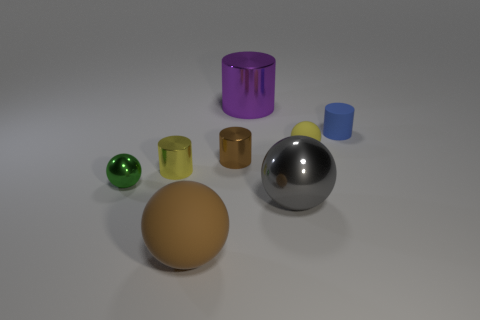Subtract all yellow cylinders. How many cylinders are left? 3 Subtract all brown spheres. How many spheres are left? 3 Add 2 tiny rubber cylinders. How many objects exist? 10 Subtract 4 balls. How many balls are left? 0 Add 8 large purple cylinders. How many large purple cylinders are left? 9 Add 2 big matte spheres. How many big matte spheres exist? 3 Subtract 0 yellow cubes. How many objects are left? 8 Subtract all blue cylinders. Subtract all blue spheres. How many cylinders are left? 3 Subtract all small yellow rubber objects. Subtract all yellow metal objects. How many objects are left? 6 